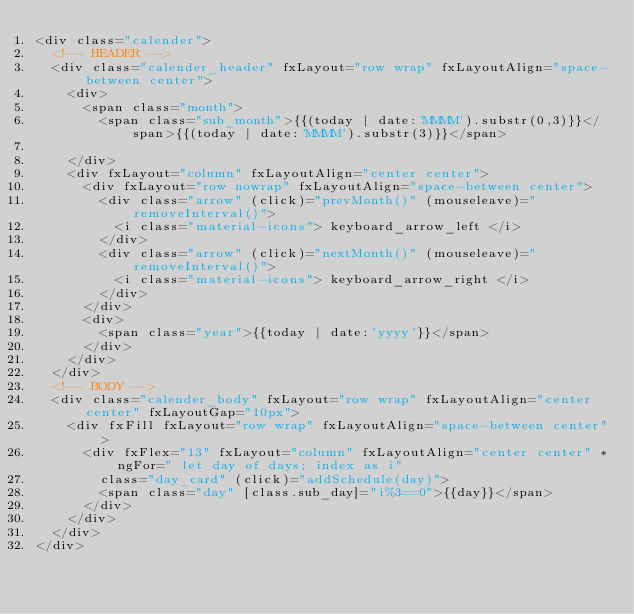<code> <loc_0><loc_0><loc_500><loc_500><_HTML_><div class="calender">
  <!-- HEADER -->
  <div class="calender_header" fxLayout="row wrap" fxLayoutAlign="space-between center">
    <div>
      <span class="month">
        <span class="sub_month">{{(today | date:'MMMM').substr(0,3)}}</span>{{(today | date:'MMMM').substr(3)}}</span>

    </div>
    <div fxLayout="column" fxLayoutAlign="center center">
      <div fxLayout="row nowrap" fxLayoutAlign="space-between center">
        <div class="arrow" (click)="prevMonth()" (mouseleave)="removeInterval()">
          <i class="material-icons"> keyboard_arrow_left </i>
        </div>
        <div class="arrow" (click)="nextMonth()" (mouseleave)="removeInterval()">
          <i class="material-icons"> keyboard_arrow_right </i>
        </div>
      </div>
      <div>
        <span class="year">{{today | date:'yyyy'}}</span>
      </div>
    </div>
  </div>
  <!-- BODY -->
  <div class="calender_body" fxLayout="row wrap" fxLayoutAlign="center center" fxLayoutGap="10px">
    <div fxFill fxLayout="row wrap" fxLayoutAlign="space-between center">
      <div fxFlex="13" fxLayout="column" fxLayoutAlign="center center" *ngFor=" let day of days; index as i"
        class="day_card" (click)="addSchedule(day)">
        <span class="day" [class.sub_day]="i%3==0">{{day}}</span>
      </div>
    </div>
  </div>
</div></code> 